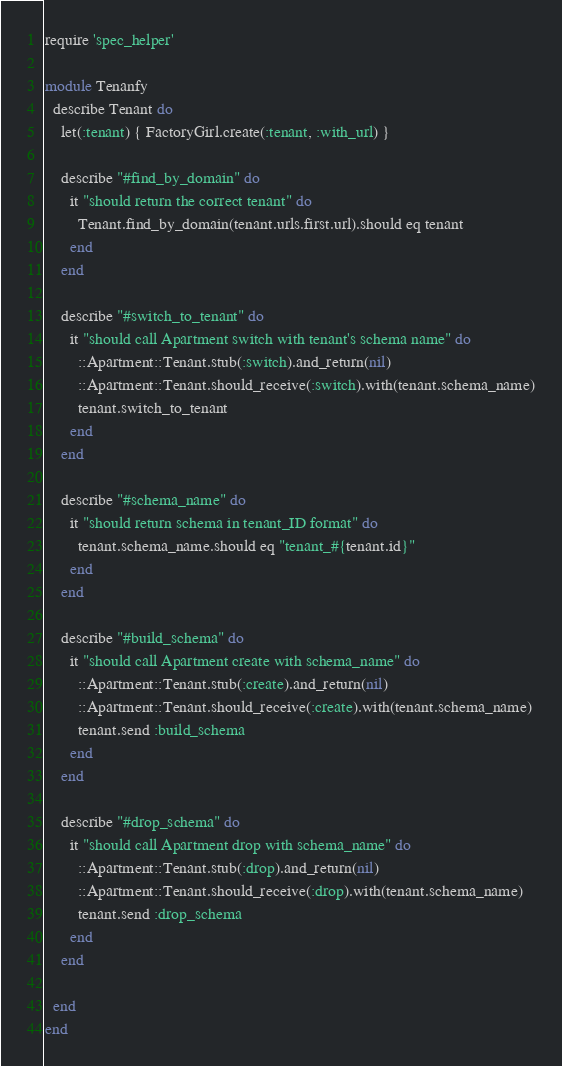Convert code to text. <code><loc_0><loc_0><loc_500><loc_500><_Ruby_>require 'spec_helper'

module Tenanfy
  describe Tenant do
    let(:tenant) { FactoryGirl.create(:tenant, :with_url) }

    describe "#find_by_domain" do
      it "should return the correct tenant" do
        Tenant.find_by_domain(tenant.urls.first.url).should eq tenant
      end
    end

    describe "#switch_to_tenant" do
      it "should call Apartment switch with tenant's schema name" do
        ::Apartment::Tenant.stub(:switch).and_return(nil)
        ::Apartment::Tenant.should_receive(:switch).with(tenant.schema_name)
        tenant.switch_to_tenant
      end
    end

    describe "#schema_name" do
      it "should return schema in tenant_ID format" do
        tenant.schema_name.should eq "tenant_#{tenant.id}"
      end
    end

    describe "#build_schema" do
      it "should call Apartment create with schema_name" do
        ::Apartment::Tenant.stub(:create).and_return(nil)
        ::Apartment::Tenant.should_receive(:create).with(tenant.schema_name)
        tenant.send :build_schema
      end
    end

    describe "#drop_schema" do
      it "should call Apartment drop with schema_name" do
        ::Apartment::Tenant.stub(:drop).and_return(nil)
        ::Apartment::Tenant.should_receive(:drop).with(tenant.schema_name)
        tenant.send :drop_schema
      end
    end

  end
end

</code> 